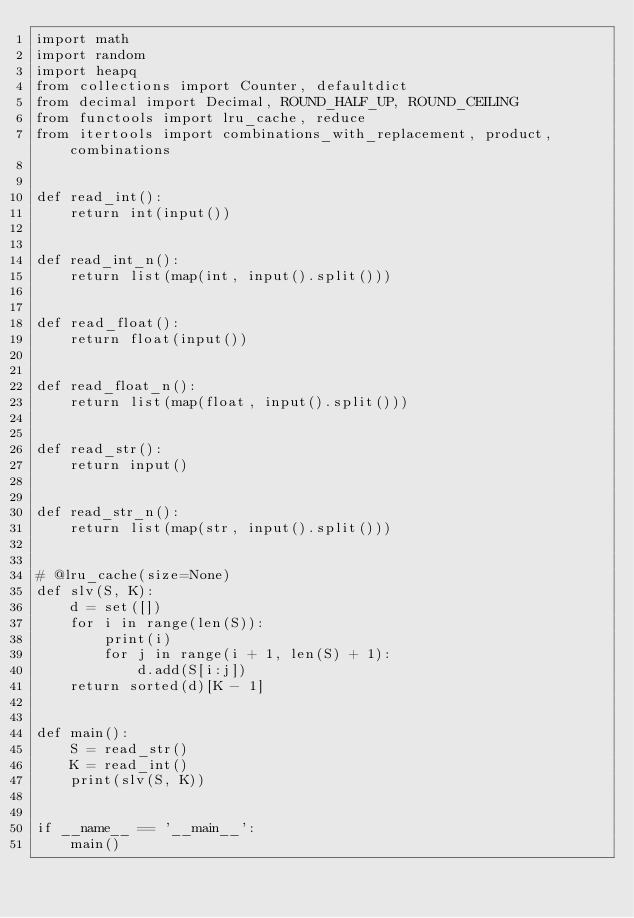<code> <loc_0><loc_0><loc_500><loc_500><_Python_>import math
import random
import heapq
from collections import Counter, defaultdict
from decimal import Decimal, ROUND_HALF_UP, ROUND_CEILING
from functools import lru_cache, reduce
from itertools import combinations_with_replacement, product, combinations


def read_int():
    return int(input())


def read_int_n():
    return list(map(int, input().split()))


def read_float():
    return float(input())


def read_float_n():
    return list(map(float, input().split()))


def read_str():
    return input()


def read_str_n():
    return list(map(str, input().split()))


# @lru_cache(size=None)
def slv(S, K):
    d = set([])
    for i in range(len(S)):
        print(i)
        for j in range(i + 1, len(S) + 1):
            d.add(S[i:j])
    return sorted(d)[K - 1]


def main():
    S = read_str()
    K = read_int()
    print(slv(S, K))


if __name__ == '__main__':
    main()</code> 